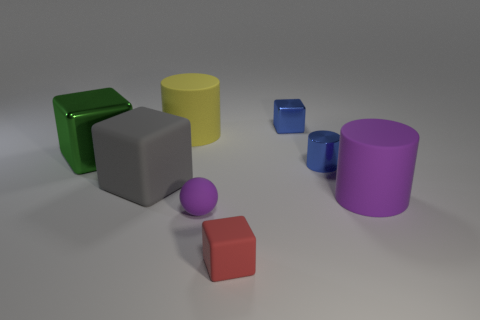Is there anything else that has the same shape as the tiny purple object?
Provide a short and direct response. No. What number of other objects have the same size as the red object?
Your answer should be compact. 3. Are there fewer small blue metal cylinders than small gray cylinders?
Provide a short and direct response. No. What shape is the purple matte object that is in front of the purple thing that is right of the red matte object?
Offer a very short reply. Sphere. What is the shape of the purple object that is the same size as the gray rubber object?
Give a very brief answer. Cylinder. Are there any other small objects of the same shape as the green metallic object?
Your response must be concise. Yes. What is the material of the yellow thing?
Offer a terse response. Rubber. Are there any yellow cylinders in front of the big green metal object?
Provide a succinct answer. No. What number of green objects are in front of the matte cylinder that is in front of the large metallic thing?
Ensure brevity in your answer.  0. There is a blue cylinder that is the same size as the sphere; what material is it?
Ensure brevity in your answer.  Metal. 